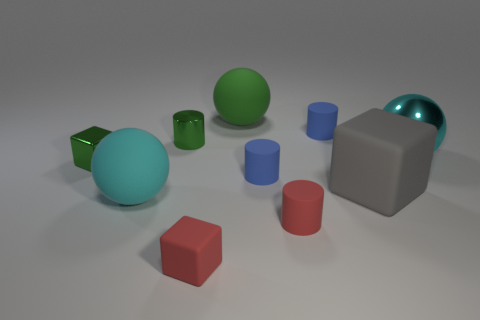Is the color of the matte ball that is behind the large gray rubber block the same as the small block that is in front of the big matte block?
Ensure brevity in your answer.  No. Are there any blue matte blocks of the same size as the cyan metal object?
Make the answer very short. No. What is the block that is both to the left of the green sphere and behind the red cube made of?
Give a very brief answer. Metal. What number of rubber objects are either large balls or tiny red cubes?
Keep it short and to the point. 3. The cyan thing that is made of the same material as the small green cylinder is what shape?
Provide a succinct answer. Sphere. What number of cyan spheres are both left of the small metal cylinder and to the right of the green cylinder?
Offer a terse response. 0. Is there any other thing that is the same shape as the large gray object?
Give a very brief answer. Yes. There is a blue cylinder in front of the cyan metallic sphere; what is its size?
Your answer should be compact. Small. What number of other objects are the same color as the big shiny sphere?
Provide a short and direct response. 1. There is a large cyan ball that is right of the small cylinder that is to the left of the green ball; what is its material?
Your answer should be very brief. Metal. 